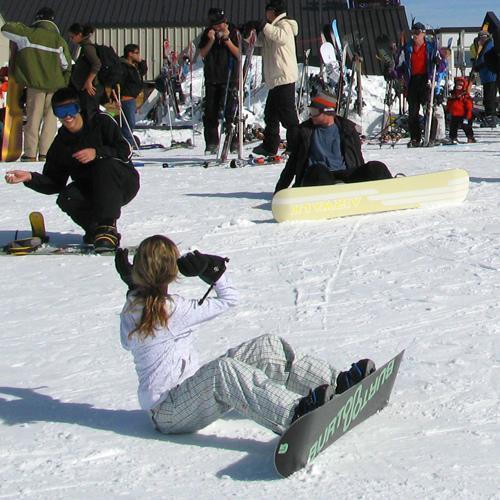How many snowboarders are sitting?
Give a very brief answer. 2. How many snowboards are in the picture?
Give a very brief answer. 2. How many people are there?
Give a very brief answer. 8. How many blue trucks are there?
Give a very brief answer. 0. 